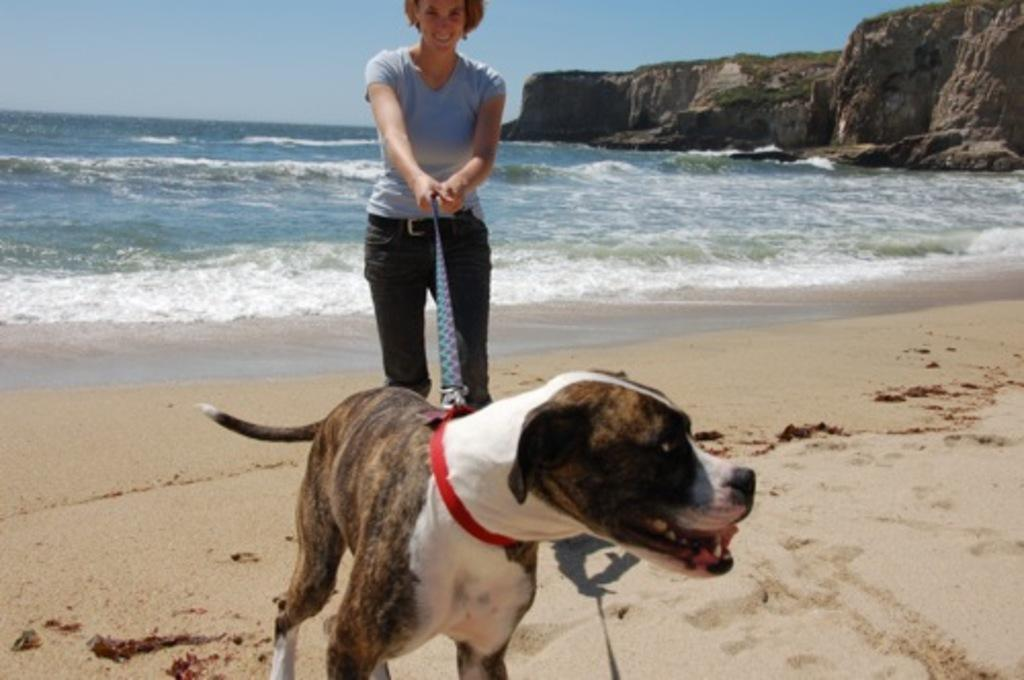What is the woman doing in the image? The woman is standing in the image and holding a belt. What is the dog's location in the image? The dog is on the snow in the image. What can be seen in the background of the image? There is water, a hill, and the sky visible in the background of the image. How many cobwebs can be seen in the image? There are no cobwebs present in the image. How many visitors are visible in the image? There are no visitors visible in the image. 